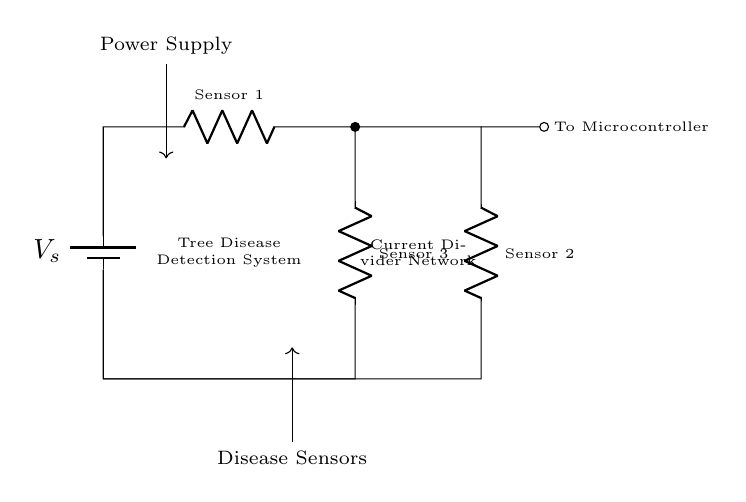What are the resistors labeled as in the circuit? The resistors in the circuit are labeled as Sensor 1, Sensor 2, and Sensor 3. These labels indicate the part of the tree disease detection system each sensor is associated with.
Answer: Sensor 1, Sensor 2, Sensor 3 What is the function of the current divider network in this circuit? The current divider network distributes the input current from the power supply into the separate current paths for each sensor. This allows for proper measurement and functioning of the sensors based on the rate of current received by them.
Answer: Distributing current How many sensors are connected to the current divider? The circuit diagram shows three resistors, which represent three different sensors connected in a current divider configuration.
Answer: Three What component supplies power to the circuit? The power supply is provided by the battery, which is indicated in the circuit diagram as the component supplying voltage throughout the network.
Answer: Battery What happens to the current flowing through the resistors? The current flowing through the resistors is divided based on their resistance values, resulting in different amounts of current flowing through each sensor. This distribution allows for the detection and measurement of tree diseases.
Answer: Divided Which component connects to the microcontroller in this circuit? The output of the current divider network connects to the microcontroller, indicated by the lead labeled "To Microcontroller." This connection allows the processed data from sensors to be read and acted upon by the microcontroller.
Answer: To Microcontroller 